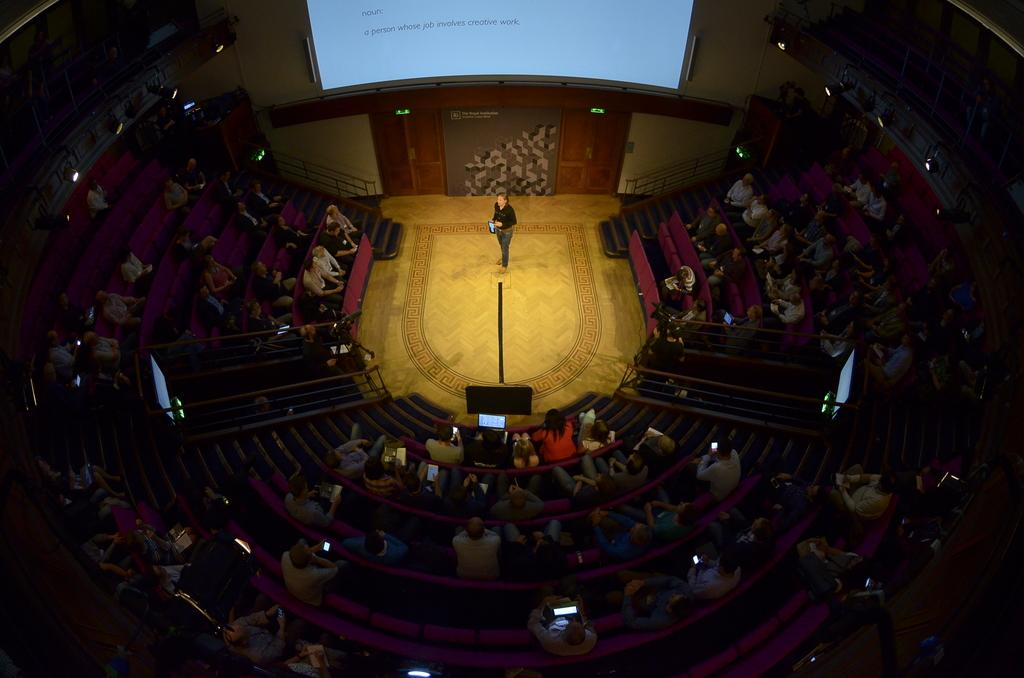How many people are in the image? There is a group of people in the image, but the exact number is not specified. What are some of the people doing in the image? Some people are sitting on chairs, some are sitting on steps, and a woman is standing on the floor. What can be seen on the wall in the image? There is a screen and lights visible on the wall. What type of zinc is being used to support the rail in the image? There is no zinc or rail present in the image. How many pickles are on the floor in the image? There are no pickles present in the image. 